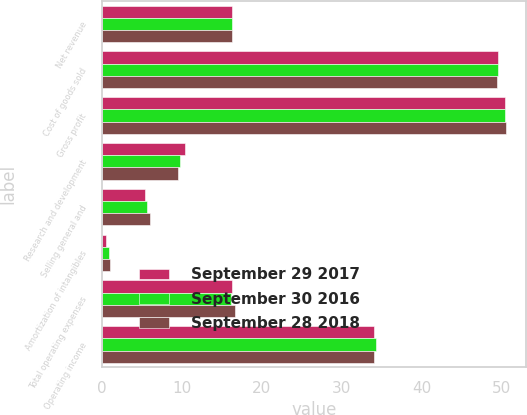Convert chart. <chart><loc_0><loc_0><loc_500><loc_500><stacked_bar_chart><ecel><fcel>Net revenue<fcel>Cost of goods sold<fcel>Gross profit<fcel>Research and development<fcel>Selling general and<fcel>Amortization of intangibles<fcel>Total operating expenses<fcel>Operating income<nl><fcel>September 29 2017<fcel>16.3<fcel>49.6<fcel>50.4<fcel>10.4<fcel>5.4<fcel>0.5<fcel>16.3<fcel>34.1<nl><fcel>September 30 2016<fcel>16.3<fcel>49.6<fcel>50.4<fcel>9.7<fcel>5.6<fcel>0.8<fcel>16.1<fcel>34.3<nl><fcel>September 28 2018<fcel>16.3<fcel>49.4<fcel>50.6<fcel>9.5<fcel>6<fcel>1<fcel>16.6<fcel>34<nl></chart> 